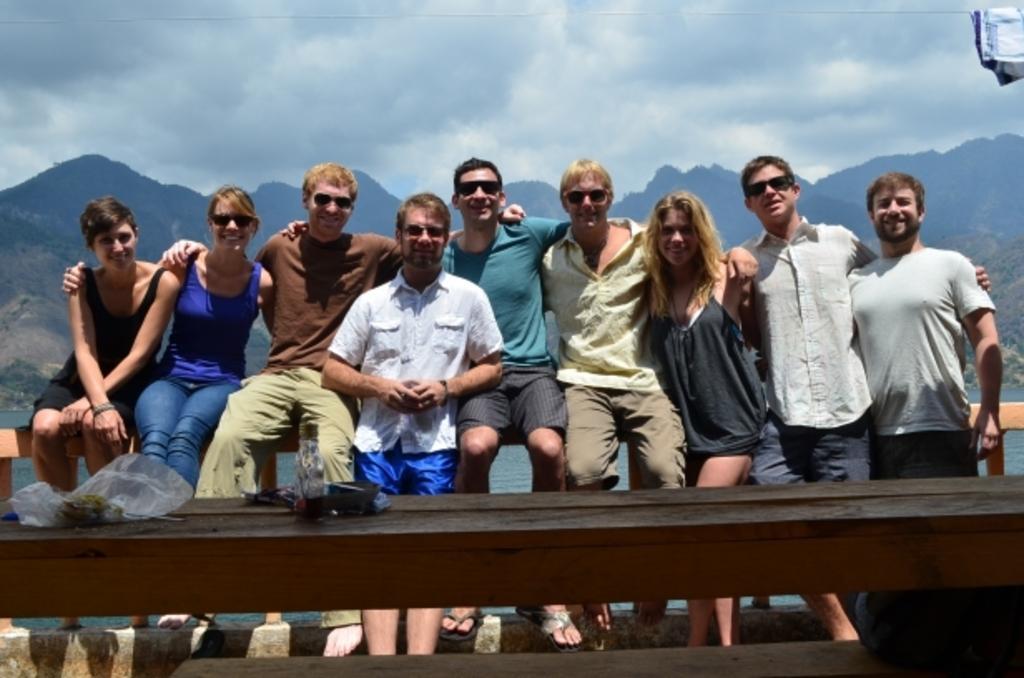Describe this image in one or two sentences. In this image we can see a group of people standing beside a wooden fence. We can also see some people sitting. In the foreground we can see a cover and a bag placed on the wooden surface. On the backside we can see a large water body, a group of trees, the hills and the sky which looks cloudy. On the top of the image we can see a cloth on a rope. 